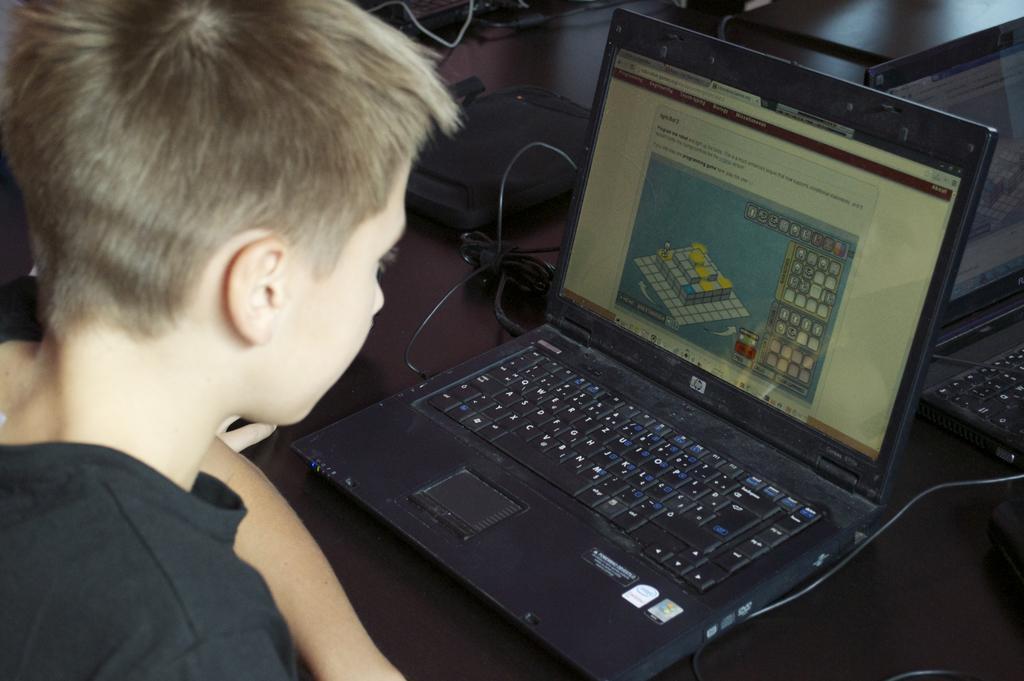Please provide a concise description of this image. In this image, we can see a person in a black dress. Here we can see a laptop and screen. So many things and objects, laptops are placed on a surface. Right side of the image, we can see another laptop here. 